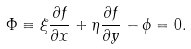<formula> <loc_0><loc_0><loc_500><loc_500>\Phi \equiv \xi \frac { \partial f } { \partial x } + \eta \frac { \partial f } { \partial y } - \phi = 0 .</formula> 